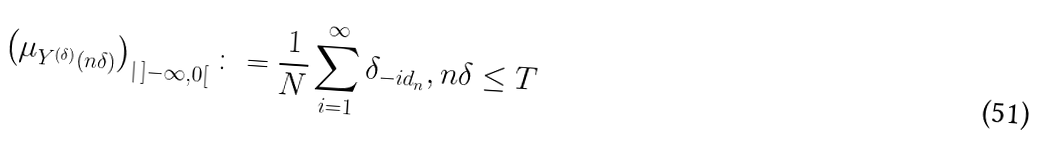<formula> <loc_0><loc_0><loc_500><loc_500>\left ( \mu _ { Y ^ { ( \delta ) } ( n \delta ) } \right ) _ { | \, ] - \infty , 0 [ } \colon = \frac { 1 } { N } \sum _ { i = 1 } ^ { \infty } \delta _ { - i d _ { n } } , n \delta \leq T</formula> 